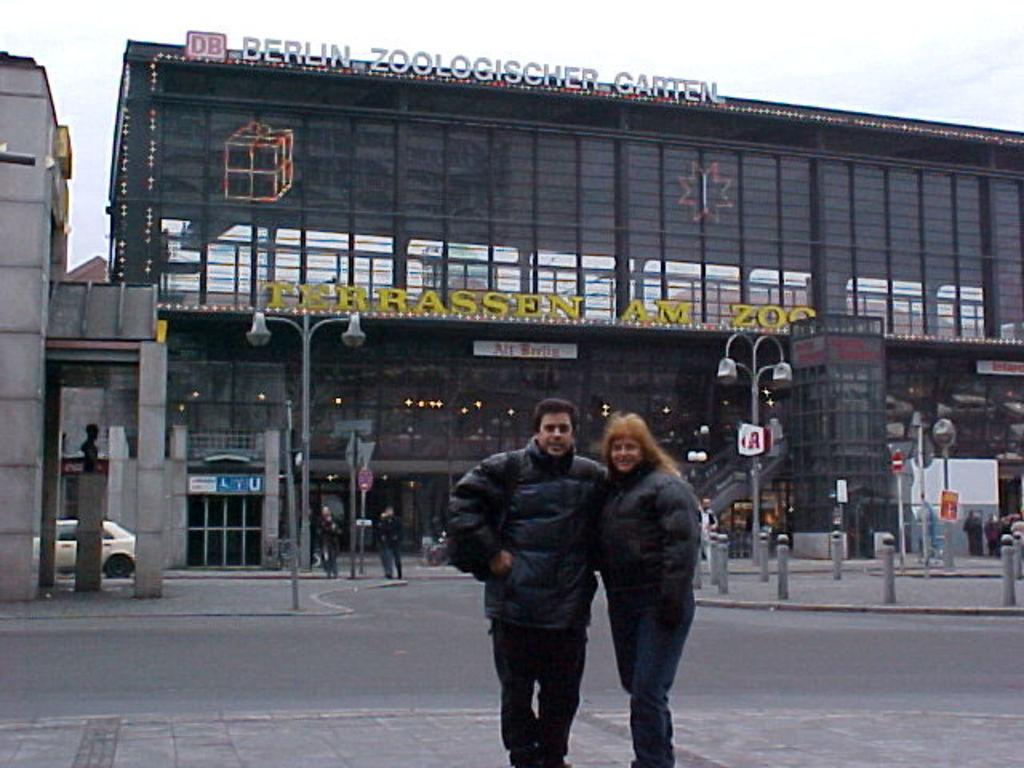How many people are on the platform in the image? There are two persons on the platform in the image. What is located on the road in the image? There is a vehicle on the road in the image. What objects can be seen in the image that are used for support or guidance? There are poles in the image. What objects in the image provide illumination? There are lights in the image. What objects in the image are used for displaying information or advertisements? There are boards in the image. What type of structures can be seen in the image? There are buildings in the image. What part of the natural environment is visible in the background of the image? The sky is visible in the background of the image. What type of loaf is being used to play music in the image? There is no loaf or music being played in the image. What type of plough is visible in the image? There is no plough present in the image. 